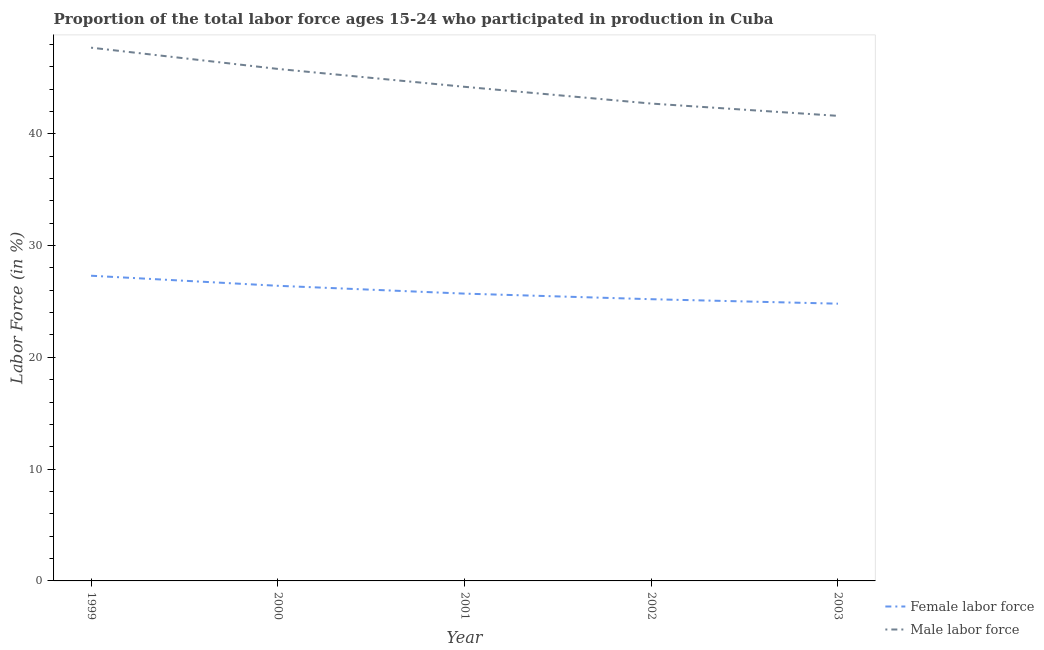What is the percentage of male labour force in 2000?
Provide a succinct answer. 45.8. Across all years, what is the maximum percentage of female labor force?
Your answer should be very brief. 27.3. Across all years, what is the minimum percentage of female labor force?
Your response must be concise. 24.8. What is the total percentage of female labor force in the graph?
Offer a terse response. 129.4. What is the difference between the percentage of female labor force in 1999 and that in 2000?
Provide a short and direct response. 0.9. What is the difference between the percentage of female labor force in 2002 and the percentage of male labour force in 2001?
Offer a very short reply. -19. What is the average percentage of female labor force per year?
Give a very brief answer. 25.88. In the year 2001, what is the difference between the percentage of male labour force and percentage of female labor force?
Keep it short and to the point. 18.5. What is the ratio of the percentage of female labor force in 1999 to that in 2003?
Keep it short and to the point. 1.1. Is the difference between the percentage of female labor force in 2000 and 2001 greater than the difference between the percentage of male labour force in 2000 and 2001?
Ensure brevity in your answer.  No. What is the difference between the highest and the second highest percentage of male labour force?
Keep it short and to the point. 1.9. What is the difference between the highest and the lowest percentage of female labor force?
Your answer should be very brief. 2.5. Is the sum of the percentage of male labour force in 1999 and 2003 greater than the maximum percentage of female labor force across all years?
Provide a succinct answer. Yes. Is the percentage of male labour force strictly less than the percentage of female labor force over the years?
Ensure brevity in your answer.  No. How many lines are there?
Keep it short and to the point. 2. What is the difference between two consecutive major ticks on the Y-axis?
Provide a short and direct response. 10. Does the graph contain any zero values?
Provide a short and direct response. No. Does the graph contain grids?
Your answer should be compact. No. How many legend labels are there?
Ensure brevity in your answer.  2. How are the legend labels stacked?
Provide a short and direct response. Vertical. What is the title of the graph?
Make the answer very short. Proportion of the total labor force ages 15-24 who participated in production in Cuba. What is the label or title of the Y-axis?
Keep it short and to the point. Labor Force (in %). What is the Labor Force (in %) in Female labor force in 1999?
Ensure brevity in your answer.  27.3. What is the Labor Force (in %) of Male labor force in 1999?
Your answer should be very brief. 47.7. What is the Labor Force (in %) of Female labor force in 2000?
Give a very brief answer. 26.4. What is the Labor Force (in %) in Male labor force in 2000?
Your answer should be very brief. 45.8. What is the Labor Force (in %) of Female labor force in 2001?
Offer a terse response. 25.7. What is the Labor Force (in %) in Male labor force in 2001?
Ensure brevity in your answer.  44.2. What is the Labor Force (in %) in Female labor force in 2002?
Your response must be concise. 25.2. What is the Labor Force (in %) in Male labor force in 2002?
Offer a terse response. 42.7. What is the Labor Force (in %) in Female labor force in 2003?
Provide a short and direct response. 24.8. What is the Labor Force (in %) in Male labor force in 2003?
Keep it short and to the point. 41.6. Across all years, what is the maximum Labor Force (in %) in Female labor force?
Offer a very short reply. 27.3. Across all years, what is the maximum Labor Force (in %) of Male labor force?
Offer a very short reply. 47.7. Across all years, what is the minimum Labor Force (in %) in Female labor force?
Offer a terse response. 24.8. Across all years, what is the minimum Labor Force (in %) in Male labor force?
Provide a succinct answer. 41.6. What is the total Labor Force (in %) of Female labor force in the graph?
Keep it short and to the point. 129.4. What is the total Labor Force (in %) in Male labor force in the graph?
Offer a terse response. 222. What is the difference between the Labor Force (in %) of Female labor force in 1999 and that in 2001?
Your answer should be compact. 1.6. What is the difference between the Labor Force (in %) in Female labor force in 1999 and that in 2002?
Provide a succinct answer. 2.1. What is the difference between the Labor Force (in %) of Female labor force in 1999 and that in 2003?
Provide a short and direct response. 2.5. What is the difference between the Labor Force (in %) in Female labor force in 2000 and that in 2002?
Your answer should be compact. 1.2. What is the difference between the Labor Force (in %) of Male labor force in 2000 and that in 2002?
Provide a succinct answer. 3.1. What is the difference between the Labor Force (in %) in Male labor force in 2000 and that in 2003?
Ensure brevity in your answer.  4.2. What is the difference between the Labor Force (in %) of Male labor force in 2002 and that in 2003?
Keep it short and to the point. 1.1. What is the difference between the Labor Force (in %) in Female labor force in 1999 and the Labor Force (in %) in Male labor force in 2000?
Provide a short and direct response. -18.5. What is the difference between the Labor Force (in %) in Female labor force in 1999 and the Labor Force (in %) in Male labor force in 2001?
Provide a succinct answer. -16.9. What is the difference between the Labor Force (in %) in Female labor force in 1999 and the Labor Force (in %) in Male labor force in 2002?
Give a very brief answer. -15.4. What is the difference between the Labor Force (in %) of Female labor force in 1999 and the Labor Force (in %) of Male labor force in 2003?
Offer a very short reply. -14.3. What is the difference between the Labor Force (in %) in Female labor force in 2000 and the Labor Force (in %) in Male labor force in 2001?
Make the answer very short. -17.8. What is the difference between the Labor Force (in %) in Female labor force in 2000 and the Labor Force (in %) in Male labor force in 2002?
Your answer should be compact. -16.3. What is the difference between the Labor Force (in %) of Female labor force in 2000 and the Labor Force (in %) of Male labor force in 2003?
Offer a very short reply. -15.2. What is the difference between the Labor Force (in %) in Female labor force in 2001 and the Labor Force (in %) in Male labor force in 2003?
Your answer should be compact. -15.9. What is the difference between the Labor Force (in %) in Female labor force in 2002 and the Labor Force (in %) in Male labor force in 2003?
Provide a short and direct response. -16.4. What is the average Labor Force (in %) of Female labor force per year?
Make the answer very short. 25.88. What is the average Labor Force (in %) of Male labor force per year?
Give a very brief answer. 44.4. In the year 1999, what is the difference between the Labor Force (in %) in Female labor force and Labor Force (in %) in Male labor force?
Offer a very short reply. -20.4. In the year 2000, what is the difference between the Labor Force (in %) in Female labor force and Labor Force (in %) in Male labor force?
Provide a succinct answer. -19.4. In the year 2001, what is the difference between the Labor Force (in %) of Female labor force and Labor Force (in %) of Male labor force?
Your answer should be compact. -18.5. In the year 2002, what is the difference between the Labor Force (in %) in Female labor force and Labor Force (in %) in Male labor force?
Ensure brevity in your answer.  -17.5. In the year 2003, what is the difference between the Labor Force (in %) of Female labor force and Labor Force (in %) of Male labor force?
Ensure brevity in your answer.  -16.8. What is the ratio of the Labor Force (in %) in Female labor force in 1999 to that in 2000?
Offer a very short reply. 1.03. What is the ratio of the Labor Force (in %) in Male labor force in 1999 to that in 2000?
Provide a succinct answer. 1.04. What is the ratio of the Labor Force (in %) of Female labor force in 1999 to that in 2001?
Offer a terse response. 1.06. What is the ratio of the Labor Force (in %) of Male labor force in 1999 to that in 2001?
Provide a succinct answer. 1.08. What is the ratio of the Labor Force (in %) of Male labor force in 1999 to that in 2002?
Give a very brief answer. 1.12. What is the ratio of the Labor Force (in %) of Female labor force in 1999 to that in 2003?
Offer a very short reply. 1.1. What is the ratio of the Labor Force (in %) of Male labor force in 1999 to that in 2003?
Offer a very short reply. 1.15. What is the ratio of the Labor Force (in %) in Female labor force in 2000 to that in 2001?
Ensure brevity in your answer.  1.03. What is the ratio of the Labor Force (in %) of Male labor force in 2000 to that in 2001?
Offer a terse response. 1.04. What is the ratio of the Labor Force (in %) of Female labor force in 2000 to that in 2002?
Your answer should be compact. 1.05. What is the ratio of the Labor Force (in %) in Male labor force in 2000 to that in 2002?
Offer a terse response. 1.07. What is the ratio of the Labor Force (in %) of Female labor force in 2000 to that in 2003?
Keep it short and to the point. 1.06. What is the ratio of the Labor Force (in %) of Male labor force in 2000 to that in 2003?
Offer a terse response. 1.1. What is the ratio of the Labor Force (in %) of Female labor force in 2001 to that in 2002?
Provide a succinct answer. 1.02. What is the ratio of the Labor Force (in %) in Male labor force in 2001 to that in 2002?
Your response must be concise. 1.04. What is the ratio of the Labor Force (in %) of Female labor force in 2001 to that in 2003?
Keep it short and to the point. 1.04. What is the ratio of the Labor Force (in %) of Male labor force in 2001 to that in 2003?
Give a very brief answer. 1.06. What is the ratio of the Labor Force (in %) in Female labor force in 2002 to that in 2003?
Give a very brief answer. 1.02. What is the ratio of the Labor Force (in %) of Male labor force in 2002 to that in 2003?
Give a very brief answer. 1.03. What is the difference between the highest and the second highest Labor Force (in %) of Female labor force?
Offer a terse response. 0.9. What is the difference between the highest and the lowest Labor Force (in %) of Female labor force?
Provide a succinct answer. 2.5. 